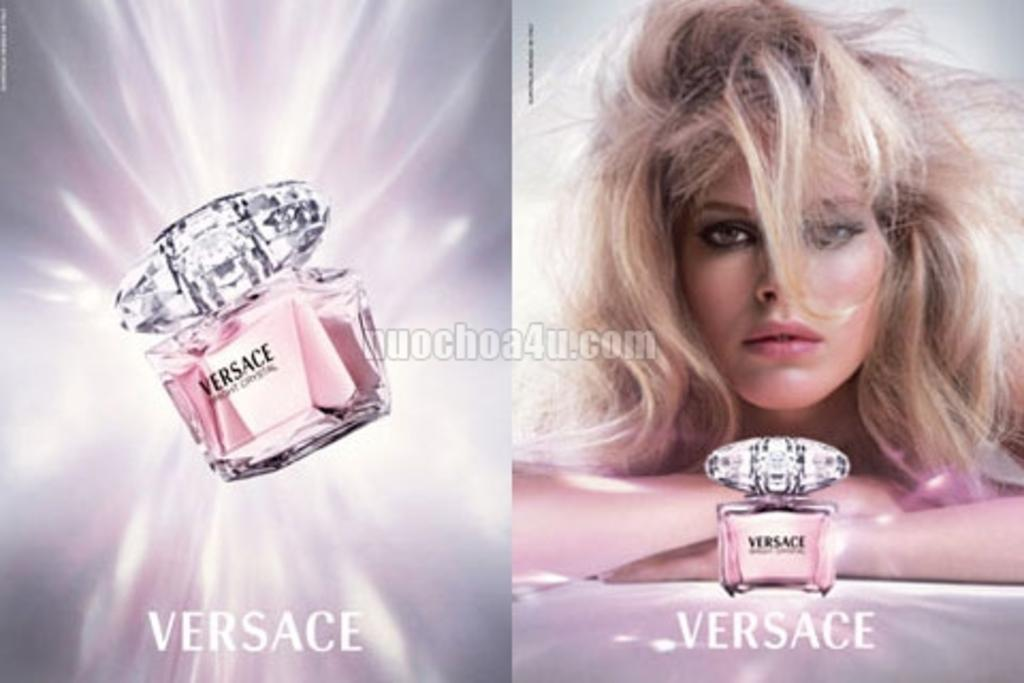Provide a one-sentence caption for the provided image. An advertisement for Versace perfume features a blonde woman with tousled hair. 